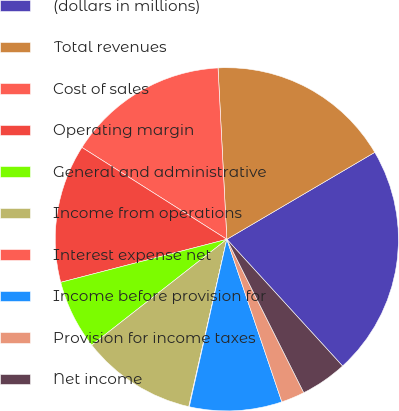<chart> <loc_0><loc_0><loc_500><loc_500><pie_chart><fcel>(dollars in millions)<fcel>Total revenues<fcel>Cost of sales<fcel>Operating margin<fcel>General and administrative<fcel>Income from operations<fcel>Interest expense net<fcel>Income before provision for<fcel>Provision for income taxes<fcel>Net income<nl><fcel>21.68%<fcel>17.36%<fcel>15.19%<fcel>13.03%<fcel>6.54%<fcel>10.87%<fcel>0.05%<fcel>8.7%<fcel>2.21%<fcel>4.38%<nl></chart> 